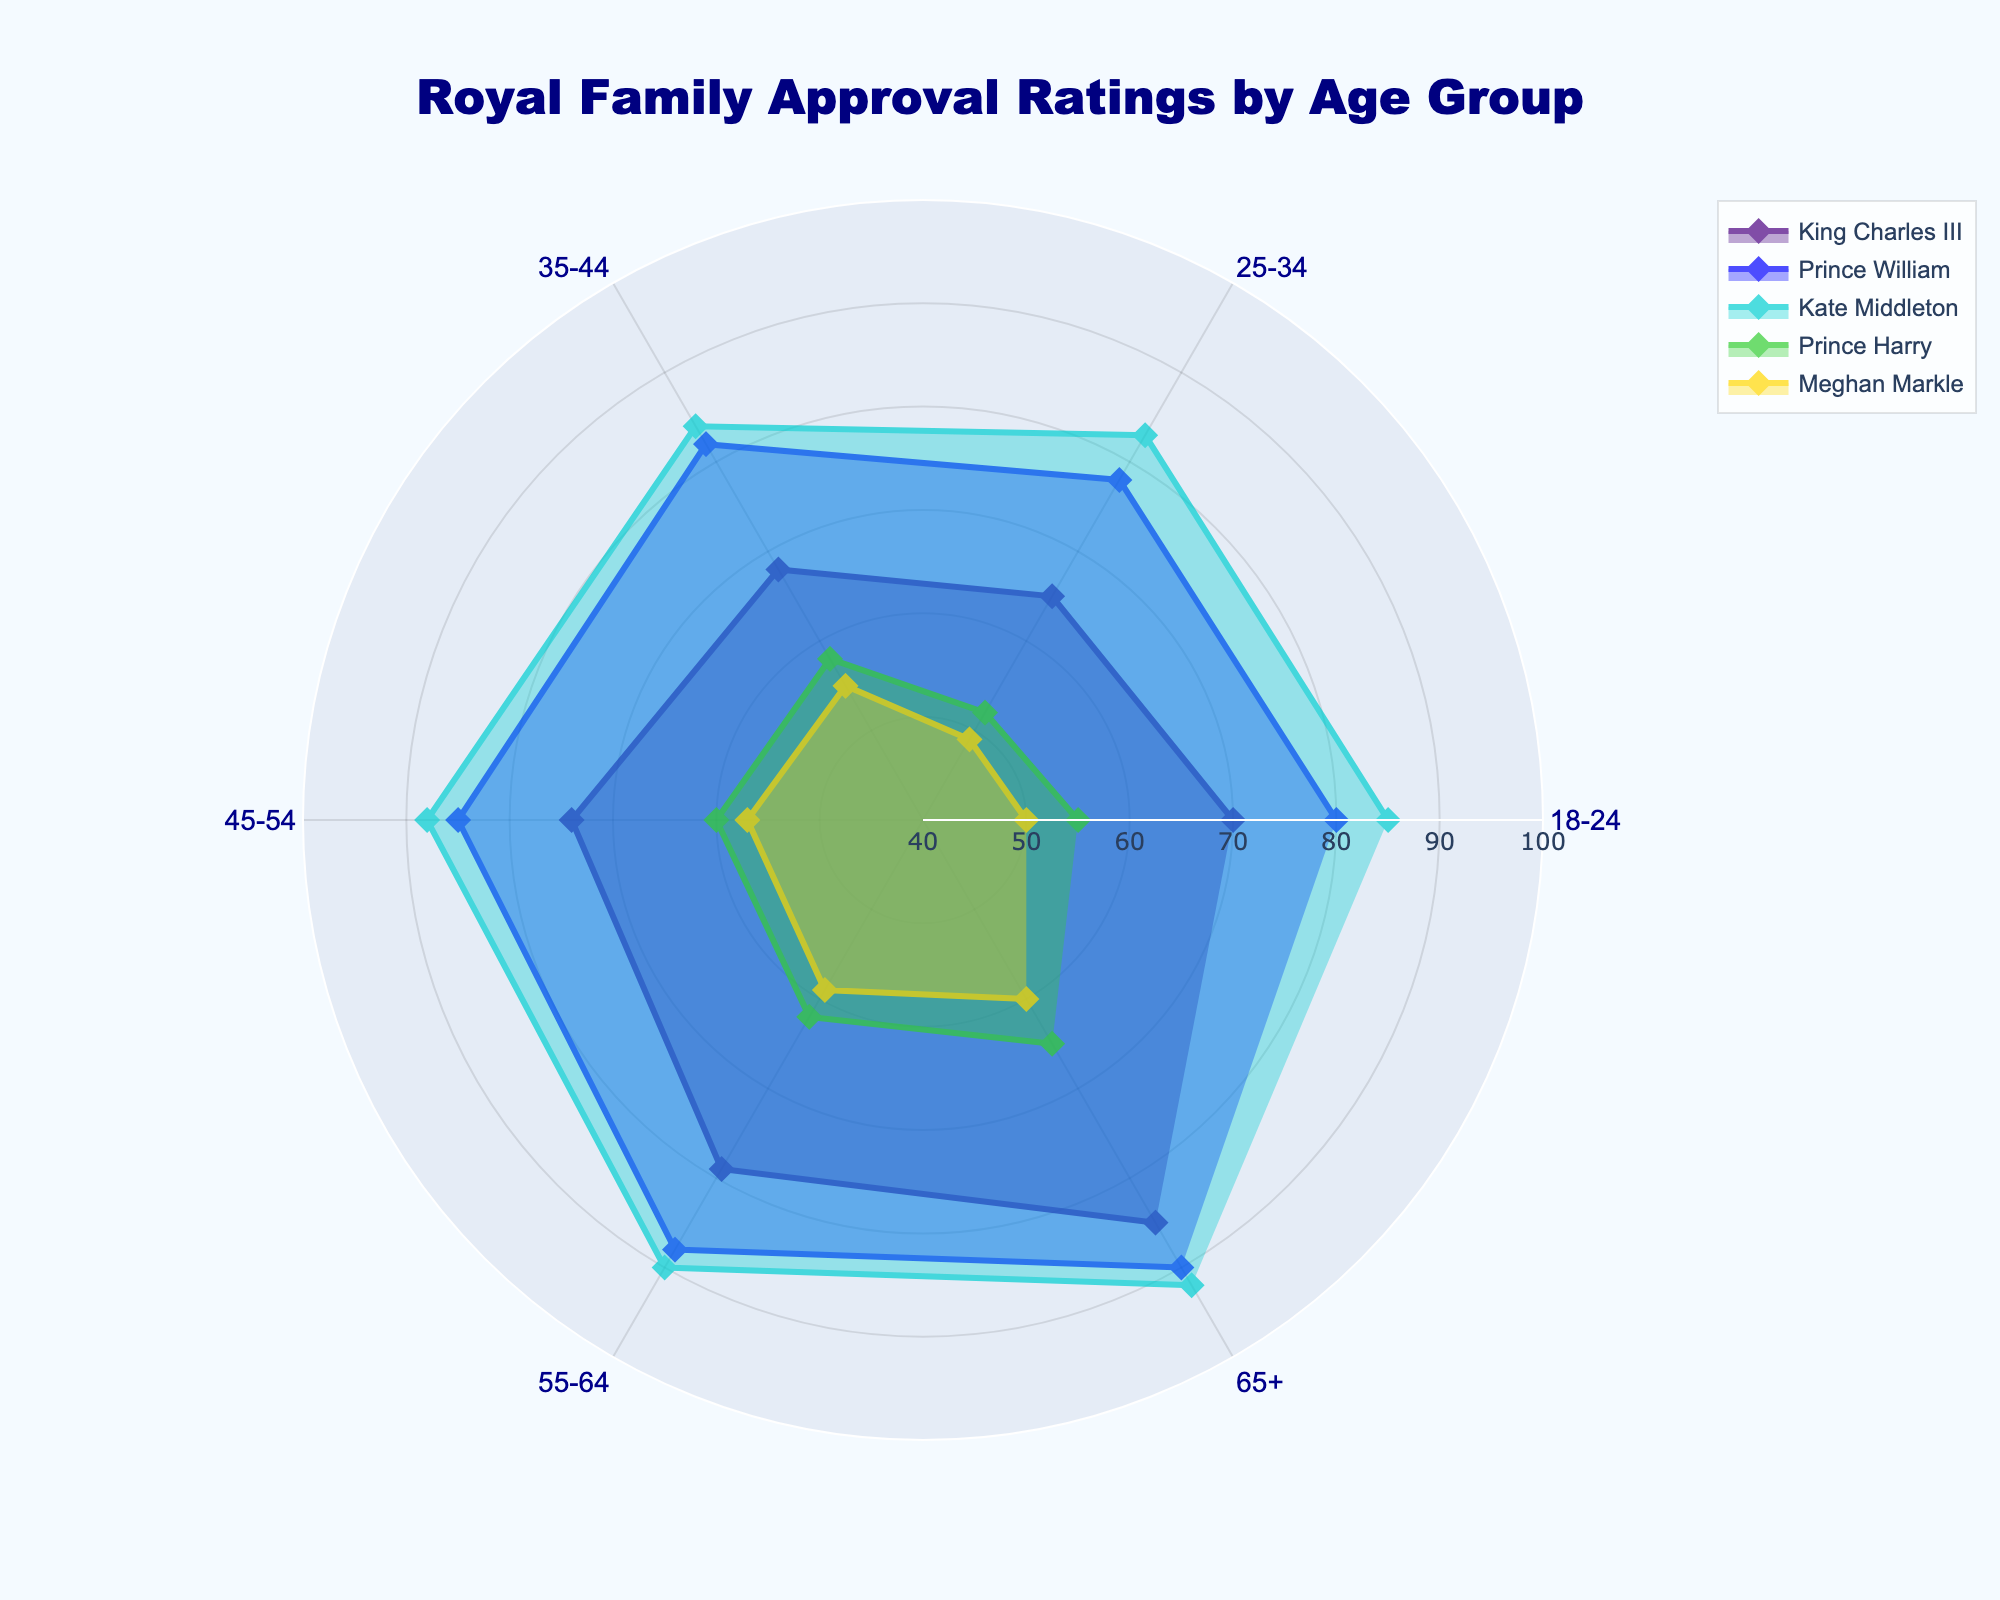Which age group has the highest approval rating for King Charles III? The highest value in the King Charles III radar line is at the age group 65+, which indicates the highest approval rating.
Answer: 65+ Which royal family member has the highest approval rating in the 45-54 age group? In the age group 45-54, Kate Middleton has the highest approval rating at 88.
Answer: Kate Middleton What is the range of approval ratings for Prince Harry across all age groups? The approval ratings for Prince Harry range from 55 (lowest for the 18-24 age group) to 65 (highest for the 65+ age group). The range is calculated as 65 - 55 = 10.
Answer: 10 Which royal has the smallest change in approval ratings between the 18-24 and 65+ age groups? King Charles III has the smallest change, with approval ratings of 70 (18-24) and 85 (65+). The change is 85 - 70 = 15.
Answer: King Charles III How does Meghan Markle's approval rating in the 55-64 age group compare to her approval rating in the 18-24 age group? In the 55-64 age group, Meghan Markle's approval rating is 59, while in the 18-24 age group, it is 50. The rating increased by 59 - 50 = 9.
Answer: It increased by 9 Who has the lowest approval rating in the 25-34 age group? The lowest approval in the 25-34 age group is Meghan Markle, with an approval rating of 49.
Answer: Meghan Markle What is the difference in Kate Middleton's approval ratings between the 35-44 and 55-64 age groups? The approval ratings for Kate Middleton in the 35-44 and 55-64 age groups are 84 and 90, respectively. The difference is 90 - 84 = 6.
Answer: 6 Who has a consistently increasing approval rating with age? King Charles III's approval ratings increase consistently with age: 70, 65, 68, 74, 79, 85.
Answer: King Charles III 